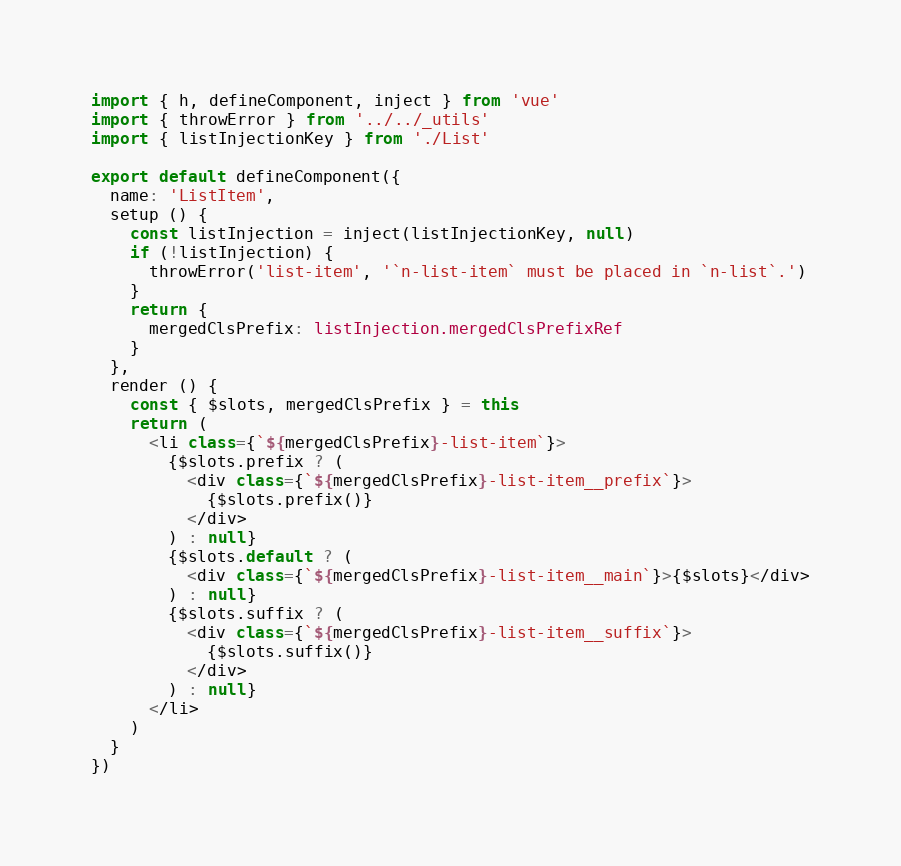Convert code to text. <code><loc_0><loc_0><loc_500><loc_500><_TypeScript_>import { h, defineComponent, inject } from 'vue'
import { throwError } from '../../_utils'
import { listInjectionKey } from './List'

export default defineComponent({
  name: 'ListItem',
  setup () {
    const listInjection = inject(listInjectionKey, null)
    if (!listInjection) {
      throwError('list-item', '`n-list-item` must be placed in `n-list`.')
    }
    return {
      mergedClsPrefix: listInjection.mergedClsPrefixRef
    }
  },
  render () {
    const { $slots, mergedClsPrefix } = this
    return (
      <li class={`${mergedClsPrefix}-list-item`}>
        {$slots.prefix ? (
          <div class={`${mergedClsPrefix}-list-item__prefix`}>
            {$slots.prefix()}
          </div>
        ) : null}
        {$slots.default ? (
          <div class={`${mergedClsPrefix}-list-item__main`}>{$slots}</div>
        ) : null}
        {$slots.suffix ? (
          <div class={`${mergedClsPrefix}-list-item__suffix`}>
            {$slots.suffix()}
          </div>
        ) : null}
      </li>
    )
  }
})
</code> 